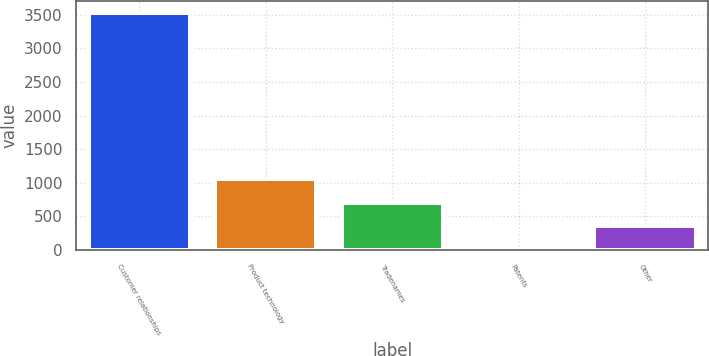Convert chart to OTSL. <chart><loc_0><loc_0><loc_500><loc_500><bar_chart><fcel>Customer relationships<fcel>Product technology<fcel>Tradenames<fcel>Patents<fcel>Other<nl><fcel>3519.8<fcel>1057.2<fcel>705.4<fcel>1.8<fcel>353.6<nl></chart> 